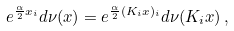<formula> <loc_0><loc_0><loc_500><loc_500>e ^ { \frac { \alpha } { 2 } x _ { i } } d \nu ( x ) = e ^ { \frac { \alpha } { 2 } ( K _ { i } x ) _ { i } } d \nu ( K _ { i } x ) \, ,</formula> 